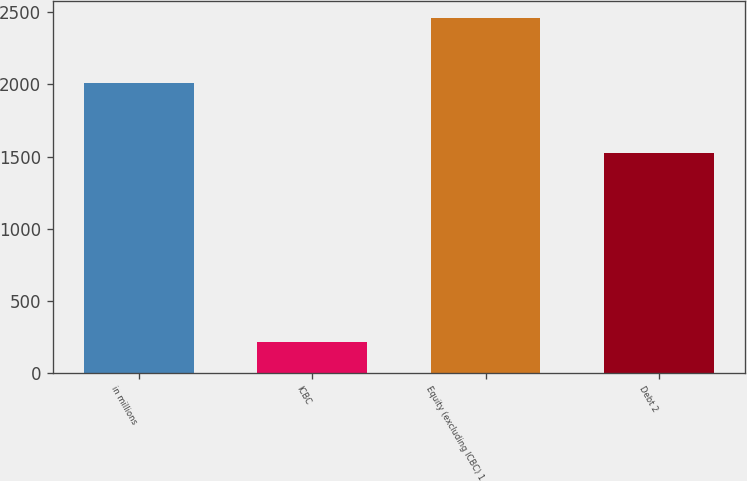<chart> <loc_0><loc_0><loc_500><loc_500><bar_chart><fcel>in millions<fcel>ICBC<fcel>Equity (excluding ICBC) 1<fcel>Debt 2<nl><fcel>2011<fcel>212<fcel>2458<fcel>1521<nl></chart> 